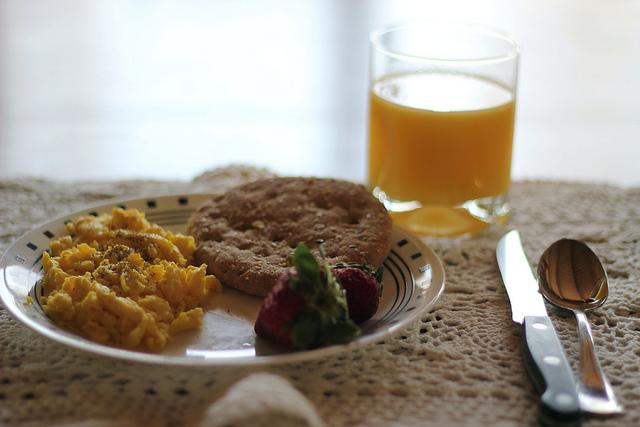What is in the glass?
Keep it brief. Orange juice. What type of food is this?
Be succinct. Breakfast. What utensils are visible in this picture?
Short answer required. Knife and spoon. What material is the tablecloth?
Answer briefly. Lace. 